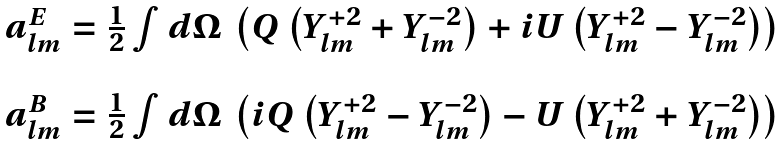<formula> <loc_0><loc_0><loc_500><loc_500>\begin{array} { c } a ^ { E } _ { l m } = \frac { 1 } { 2 } \int d \Omega \, \left ( Q \left ( Y ^ { + 2 } _ { l m } + Y ^ { - 2 } _ { l m } \right ) + i U \left ( Y ^ { + 2 } _ { l m } - Y ^ { - 2 } _ { l m } \right ) \right ) \\ \\ a ^ { B } _ { l m } = \frac { 1 } { 2 } \int d \Omega \, \left ( i Q \left ( Y ^ { + 2 } _ { l m } - Y ^ { - 2 } _ { l m } \right ) - U \left ( Y ^ { + 2 } _ { l m } + Y ^ { - 2 } _ { l m } \right ) \right ) \end{array}</formula> 